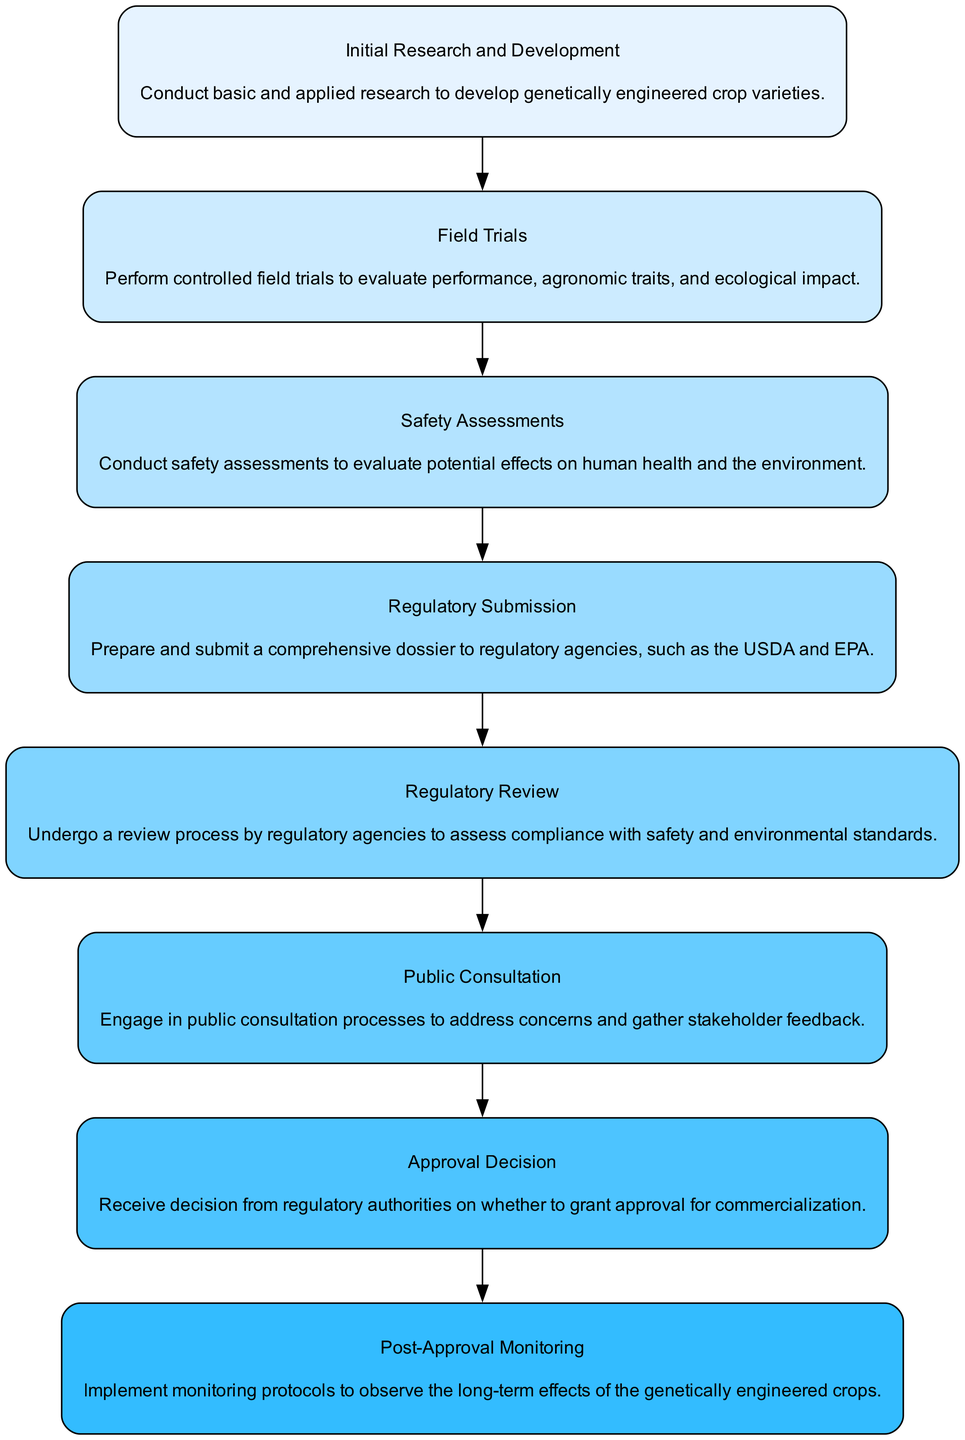What is the first step in the regulatory approval process? The first step listed in the flow chart is "Initial Research and Development," which involves conducting basic and applied research to develop genetically engineered crop varieties.
Answer: Initial Research and Development How many steps are in the process? By counting the elements in the flow chart, there are a total of eight steps from "Initial Research and Development" to "Post-Approval Monitoring."
Answer: Eight What follows after the "Regulatory Review"? After the "Regulatory Review," the next step in the process is "Public Consultation," where concerns are addressed and stakeholder feedback is gathered.
Answer: Public Consultation Which step involves evaluating potential effects on human health? The step that involves evaluating potential effects on human health is "Safety Assessments." This step is specifically designed to assess safety aspects before approval.
Answer: Safety Assessments What is the last step in the regulatory approval process? The last step shown in the flow chart is "Post-Approval Monitoring," which implements protocols to observe the long-term effects of genetically engineered crops after they have been approved.
Answer: Post-Approval Monitoring Which two steps are directly connected? "Regulatory Submission" and "Regulatory Review" are directly connected. The flow from "Regulatory Submission" leads to a review of the submitted dossier by the regulatory agencies.
Answer: Regulatory Submission, Regulatory Review What is the purpose of the "Field Trials" stage? The purpose of the "Field Trials" stage is to evaluate performance, agronomic traits, and ecological impact of genetically engineered crop varieties before regulatory submission.
Answer: Evaluate performance, agronomic traits, and ecological impact During which step is stakeholder feedback gathered? Stakeholder feedback is gathered during the "Public Consultation" step, where engagement with the public occurs to address concerns regarding the genetically engineered crop varieties.
Answer: Public Consultation 